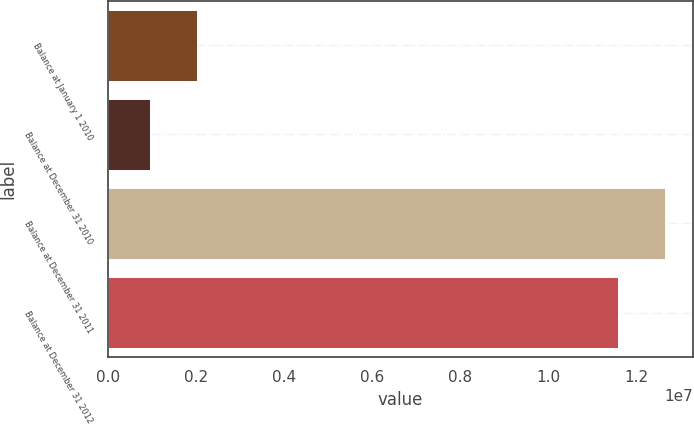Convert chart. <chart><loc_0><loc_0><loc_500><loc_500><bar_chart><fcel>Balance at January 1 2010<fcel>Balance at December 31 2010<fcel>Balance at December 31 2011<fcel>Balance at December 31 2012<nl><fcel>2.02601e+06<fcel>947497<fcel>1.2655e+07<fcel>1.15765e+07<nl></chart> 